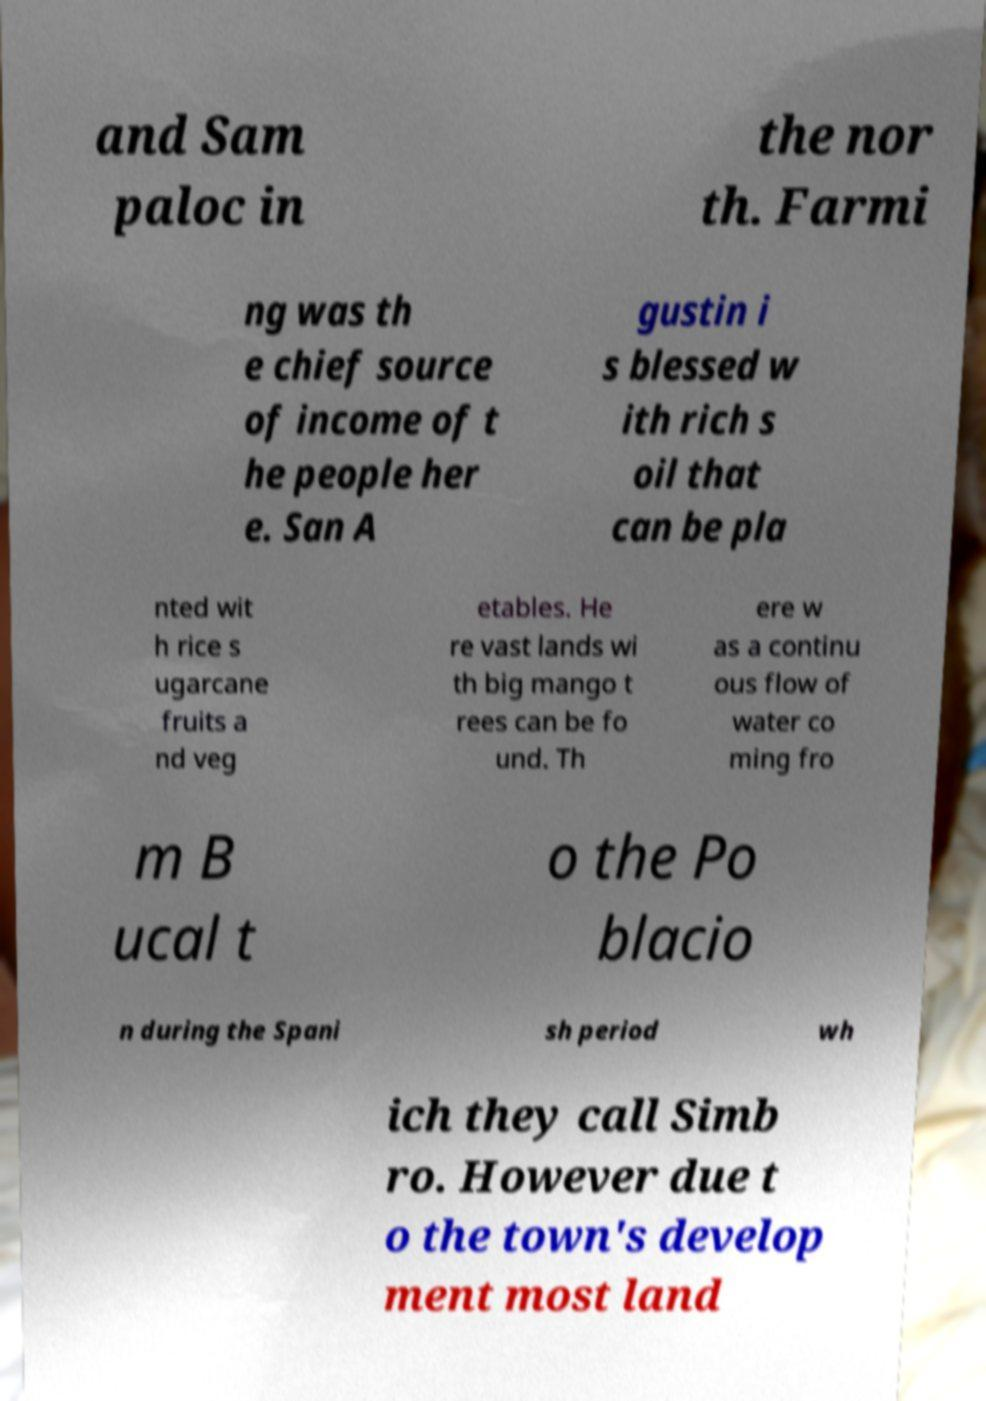For documentation purposes, I need the text within this image transcribed. Could you provide that? and Sam paloc in the nor th. Farmi ng was th e chief source of income of t he people her e. San A gustin i s blessed w ith rich s oil that can be pla nted wit h rice s ugarcane fruits a nd veg etables. He re vast lands wi th big mango t rees can be fo und. Th ere w as a continu ous flow of water co ming fro m B ucal t o the Po blacio n during the Spani sh period wh ich they call Simb ro. However due t o the town's develop ment most land 